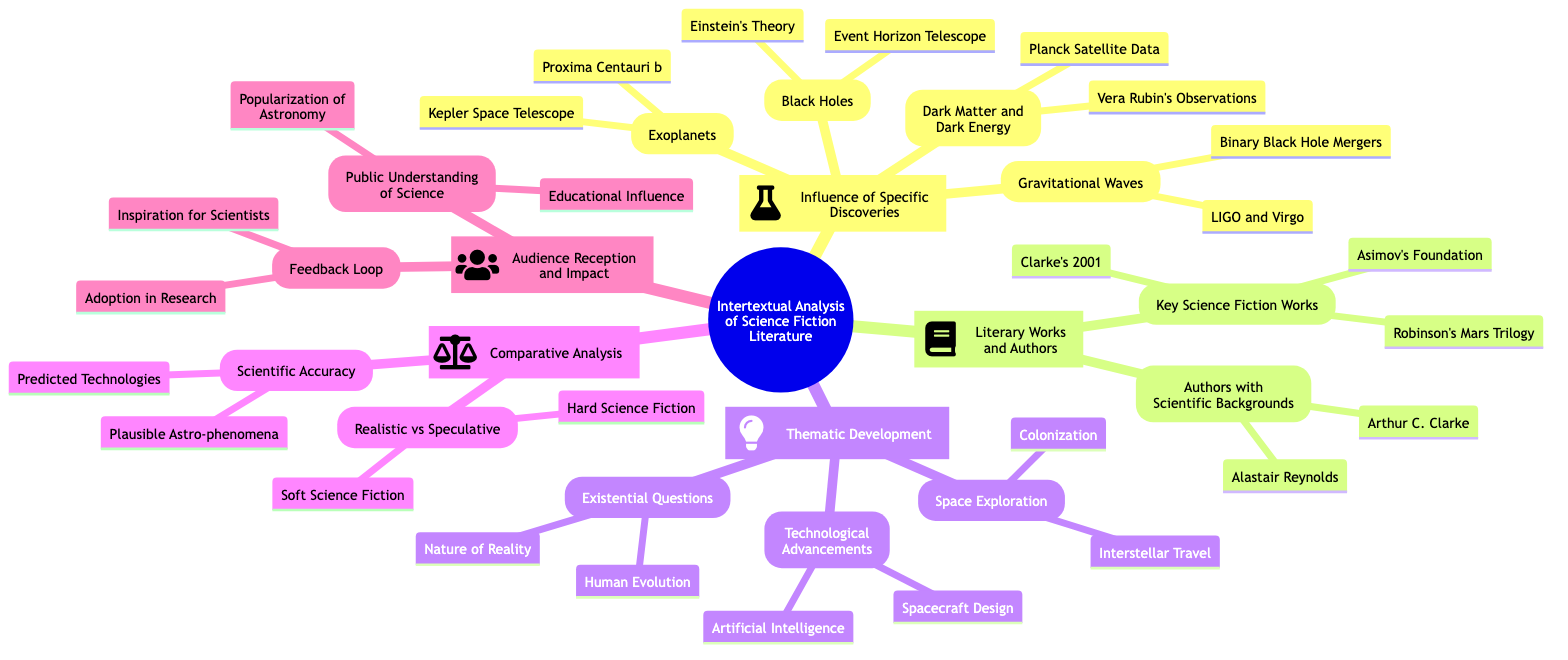What are two branches under "Influence of Specific Discoveries"? The diagram lists "Black Holes" and "Exoplanets" as two of the branches under "Influence of Specific Discoveries."
Answer: Black Holes, Exoplanets Which key author is noted for scientific background in the diagram? The diagram highlights "Arthur C. Clarke" as an author with a scientific background.
Answer: Arthur C. Clarke How many main branches are in the mind map? Counting the main branches labeled from 1 to 5, there are five distinct branches in the mind map.
Answer: 5 What is one theme specifically associated with "Technological Advancements"? The diagram shows "Artificial Intelligence" as one of the themes under "Technological Advancements."
Answer: Artificial Intelligence What discovery is linked to the "Event Horizon Telescope"? The "Event Horizon Telescope" is specifically associated with the "Black Holes" sub-branch within the influence of specific discoveries.
Answer: Black Holes What type of science fiction is contrasted with "Soft Science Fiction" in the mind map? The mind map contrasts "Hard Science Fiction" with "Soft Science Fiction" under the comparative analysis section.
Answer: Hard Science Fiction Which discovery's influence includes "Vera Rubin's Observations"? "Vera Rubin's Observations" is linked to the sub-branch "Dark Matter and Dark Energy" in the mind map.
Answer: Dark Matter and Dark Energy What impact does the mind map suggest regarding the "Public Understanding of Science"? The section under "Audience Reception and Impact" mentions "Educational Influence" as an impact on public understanding of science.
Answer: Educational Influence How are "Gravitational Waves" related to the concept of detection? "Gravitational Waves" are associated with "LIGO and Virgo Collaborations" under the influence of specific discoveries in terms of detection.
Answer: LIGO and Virgo Collaborations 